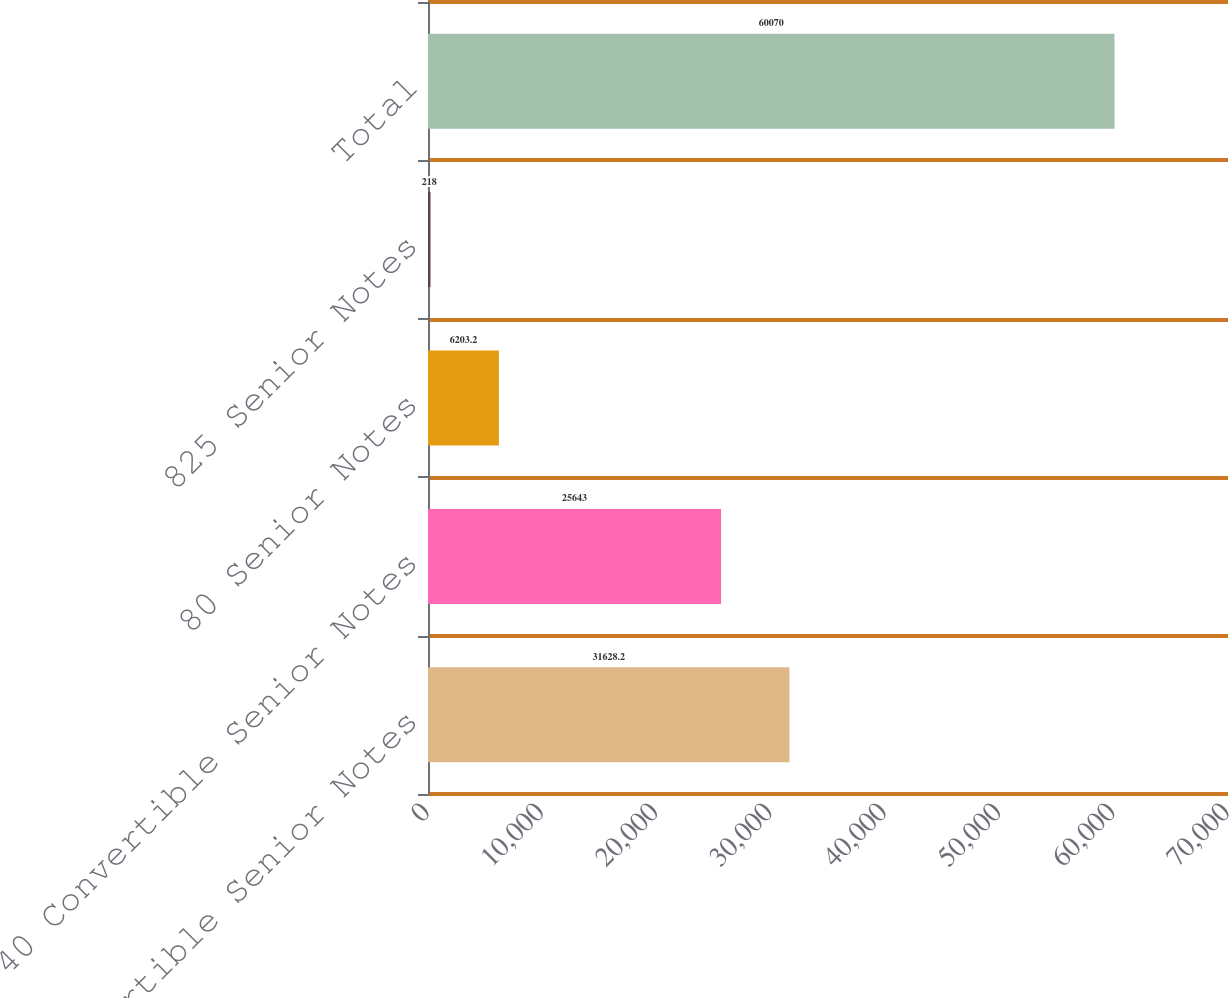<chart> <loc_0><loc_0><loc_500><loc_500><bar_chart><fcel>1875 Convertible Senior Notes<fcel>40 Convertible Senior Notes<fcel>80 Senior Notes<fcel>825 Senior Notes<fcel>Total<nl><fcel>31628.2<fcel>25643<fcel>6203.2<fcel>218<fcel>60070<nl></chart> 